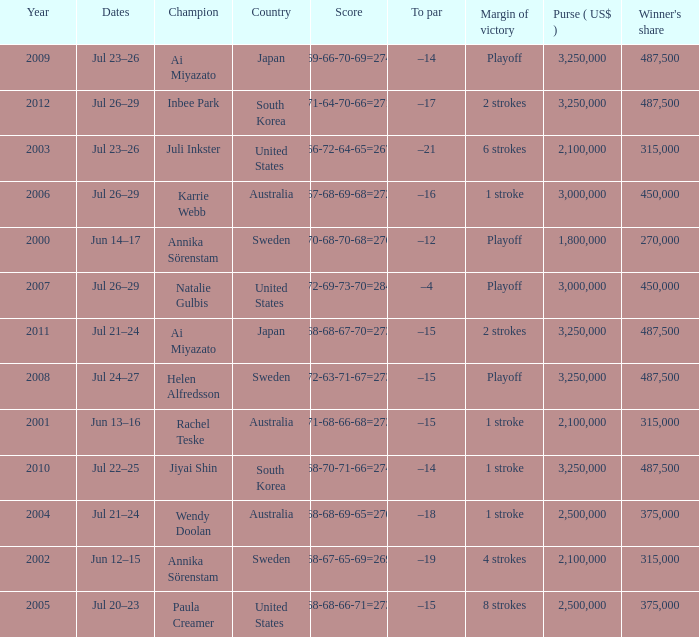Which Country has a Score of 70-68-70-68=276? Sweden. 